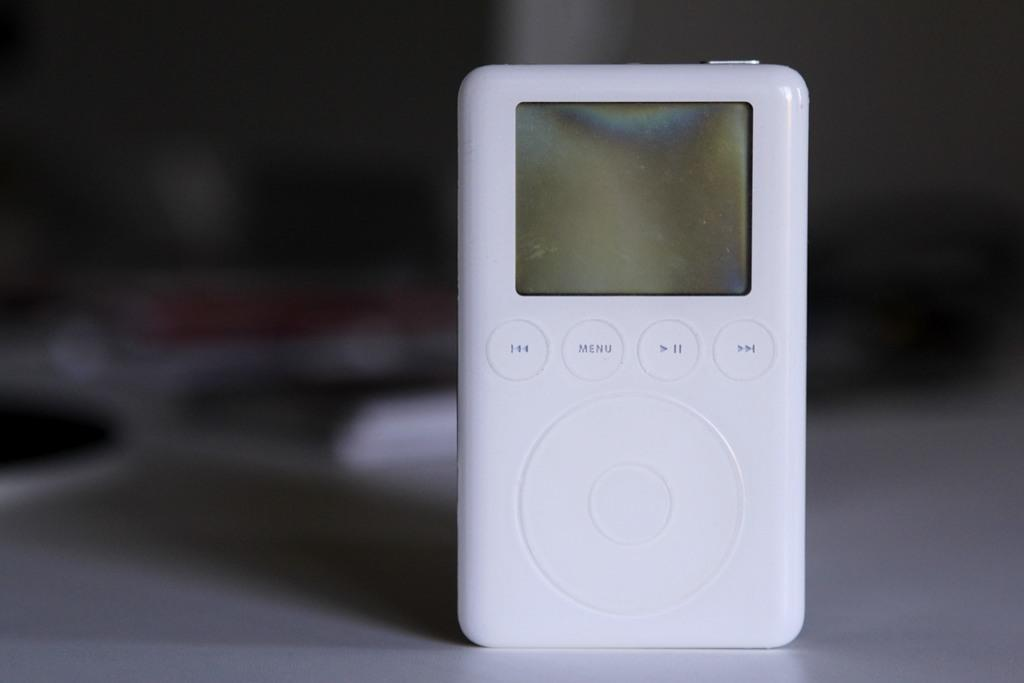What electronic device is visible in the image? There is an iPod in the image. Can you describe the background of the image? The background of the image is blurred. What type of leather is used to make the iPod's case in the image? There is no information about the iPod's case in the image, and no mention of leather. 